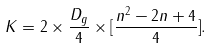Convert formula to latex. <formula><loc_0><loc_0><loc_500><loc_500>K = 2 \times \frac { D _ { g } } { 4 } \times [ \frac { n ^ { 2 } - 2 n + 4 } { 4 } ] .</formula> 